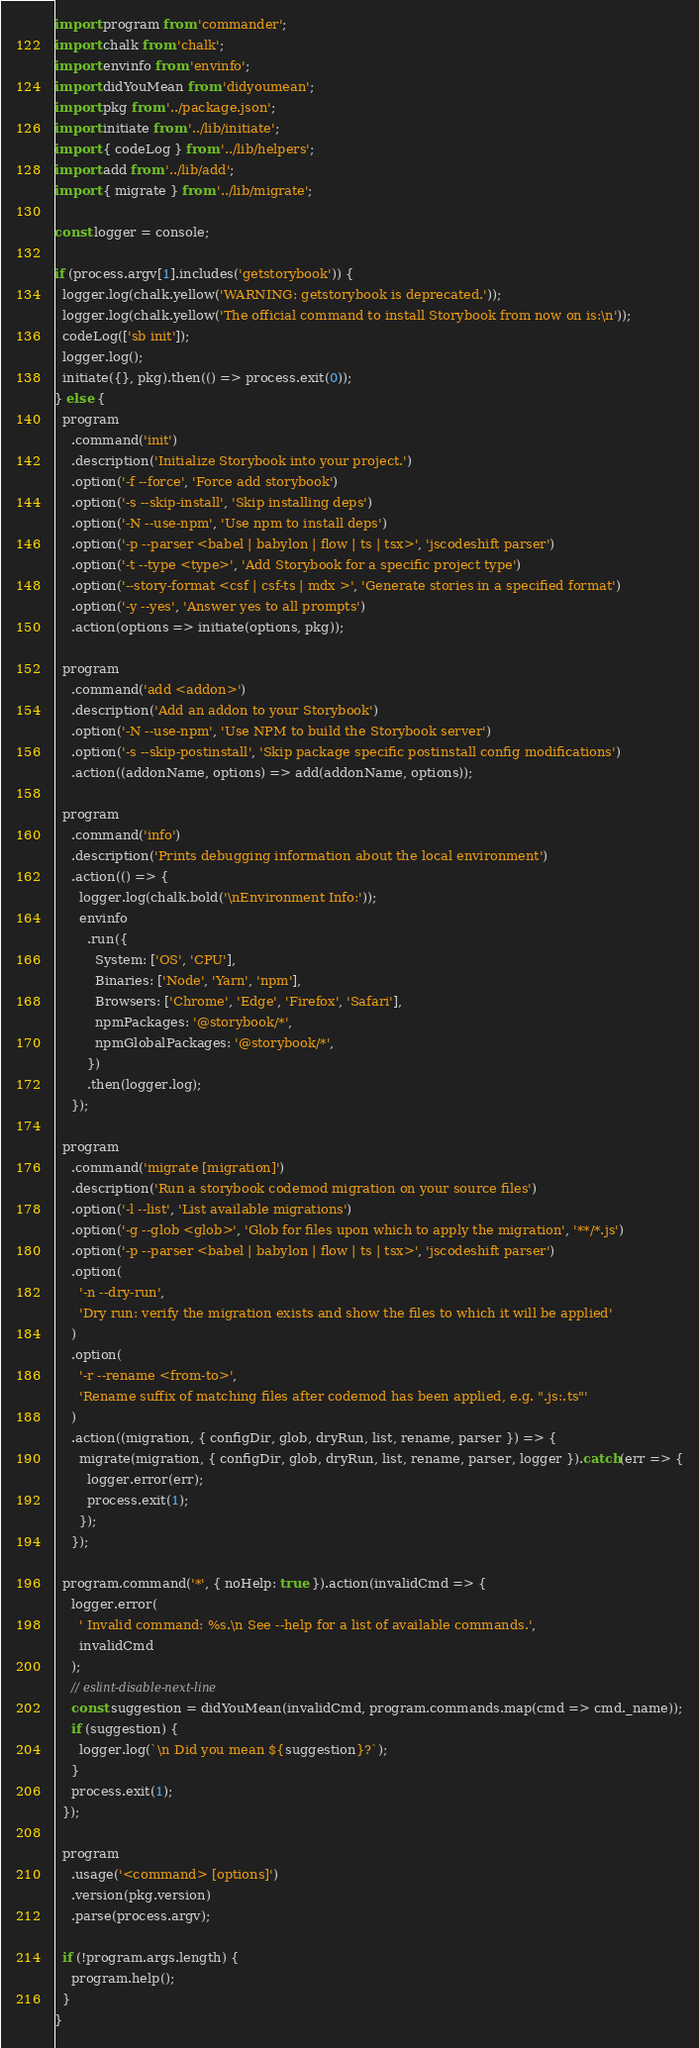<code> <loc_0><loc_0><loc_500><loc_500><_JavaScript_>import program from 'commander';
import chalk from 'chalk';
import envinfo from 'envinfo';
import didYouMean from 'didyoumean';
import pkg from '../package.json';
import initiate from '../lib/initiate';
import { codeLog } from '../lib/helpers';
import add from '../lib/add';
import { migrate } from '../lib/migrate';

const logger = console;

if (process.argv[1].includes('getstorybook')) {
  logger.log(chalk.yellow('WARNING: getstorybook is deprecated.'));
  logger.log(chalk.yellow('The official command to install Storybook from now on is:\n'));
  codeLog(['sb init']);
  logger.log();
  initiate({}, pkg).then(() => process.exit(0));
} else {
  program
    .command('init')
    .description('Initialize Storybook into your project.')
    .option('-f --force', 'Force add storybook')
    .option('-s --skip-install', 'Skip installing deps')
    .option('-N --use-npm', 'Use npm to install deps')
    .option('-p --parser <babel | babylon | flow | ts | tsx>', 'jscodeshift parser')
    .option('-t --type <type>', 'Add Storybook for a specific project type')
    .option('--story-format <csf | csf-ts | mdx >', 'Generate stories in a specified format')
    .option('-y --yes', 'Answer yes to all prompts')
    .action(options => initiate(options, pkg));

  program
    .command('add <addon>')
    .description('Add an addon to your Storybook')
    .option('-N --use-npm', 'Use NPM to build the Storybook server')
    .option('-s --skip-postinstall', 'Skip package specific postinstall config modifications')
    .action((addonName, options) => add(addonName, options));

  program
    .command('info')
    .description('Prints debugging information about the local environment')
    .action(() => {
      logger.log(chalk.bold('\nEnvironment Info:'));
      envinfo
        .run({
          System: ['OS', 'CPU'],
          Binaries: ['Node', 'Yarn', 'npm'],
          Browsers: ['Chrome', 'Edge', 'Firefox', 'Safari'],
          npmPackages: '@storybook/*',
          npmGlobalPackages: '@storybook/*',
        })
        .then(logger.log);
    });

  program
    .command('migrate [migration]')
    .description('Run a storybook codemod migration on your source files')
    .option('-l --list', 'List available migrations')
    .option('-g --glob <glob>', 'Glob for files upon which to apply the migration', '**/*.js')
    .option('-p --parser <babel | babylon | flow | ts | tsx>', 'jscodeshift parser')
    .option(
      '-n --dry-run',
      'Dry run: verify the migration exists and show the files to which it will be applied'
    )
    .option(
      '-r --rename <from-to>',
      'Rename suffix of matching files after codemod has been applied, e.g. ".js:.ts"'
    )
    .action((migration, { configDir, glob, dryRun, list, rename, parser }) => {
      migrate(migration, { configDir, glob, dryRun, list, rename, parser, logger }).catch(err => {
        logger.error(err);
        process.exit(1);
      });
    });

  program.command('*', { noHelp: true }).action(invalidCmd => {
    logger.error(
      ' Invalid command: %s.\n See --help for a list of available commands.',
      invalidCmd
    );
    // eslint-disable-next-line
    const suggestion = didYouMean(invalidCmd, program.commands.map(cmd => cmd._name));
    if (suggestion) {
      logger.log(`\n Did you mean ${suggestion}?`);
    }
    process.exit(1);
  });

  program
    .usage('<command> [options]')
    .version(pkg.version)
    .parse(process.argv);

  if (!program.args.length) {
    program.help();
  }
}
</code> 